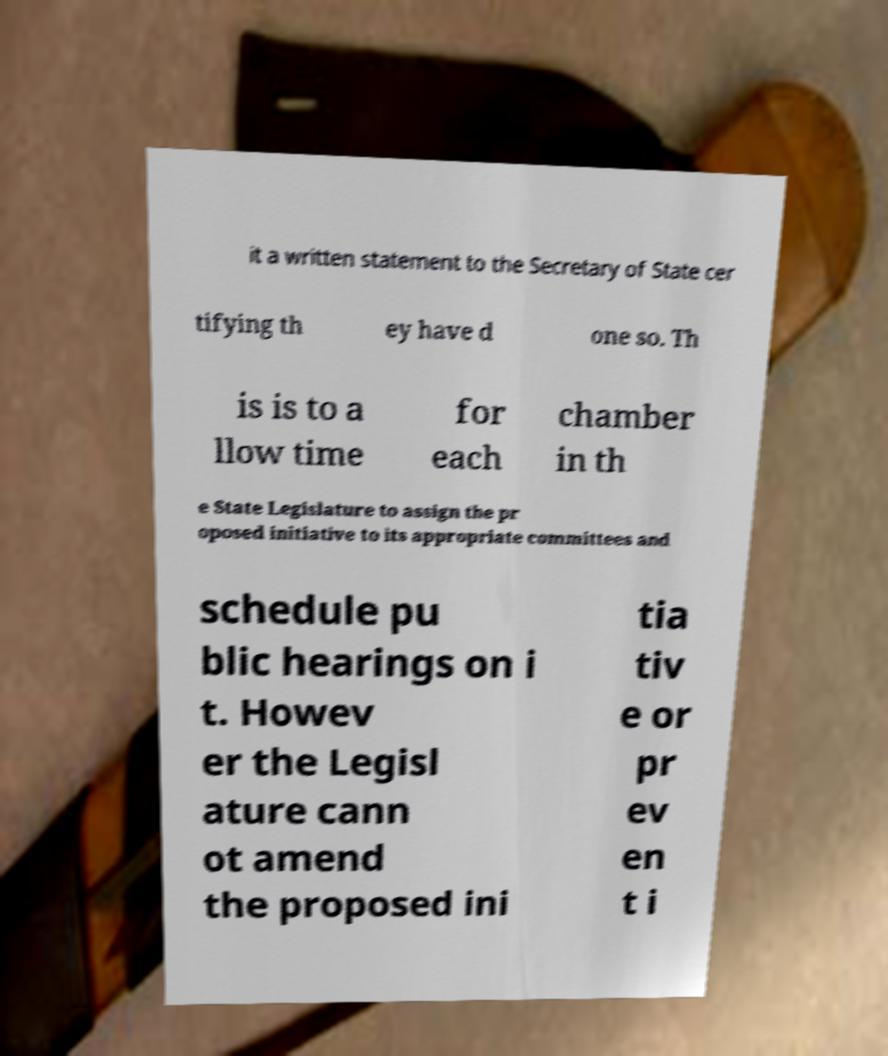What messages or text are displayed in this image? I need them in a readable, typed format. it a written statement to the Secretary of State cer tifying th ey have d one so. Th is is to a llow time for each chamber in th e State Legislature to assign the pr oposed initiative to its appropriate committees and schedule pu blic hearings on i t. Howev er the Legisl ature cann ot amend the proposed ini tia tiv e or pr ev en t i 